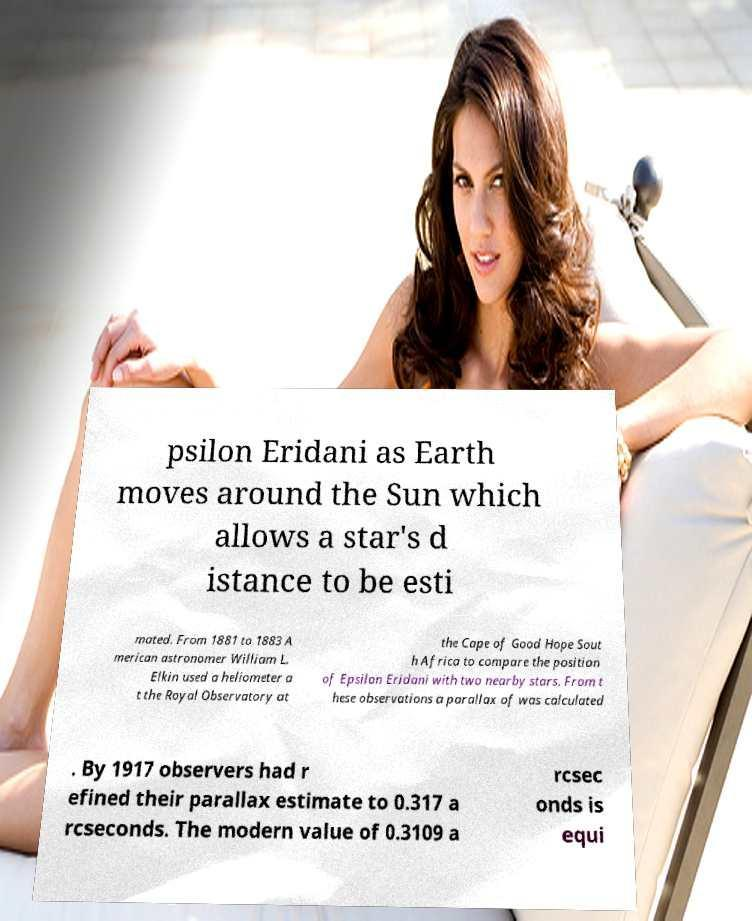For documentation purposes, I need the text within this image transcribed. Could you provide that? psilon Eridani as Earth moves around the Sun which allows a star's d istance to be esti mated. From 1881 to 1883 A merican astronomer William L. Elkin used a heliometer a t the Royal Observatory at the Cape of Good Hope Sout h Africa to compare the position of Epsilon Eridani with two nearby stars. From t hese observations a parallax of was calculated . By 1917 observers had r efined their parallax estimate to 0.317 a rcseconds. The modern value of 0.3109 a rcsec onds is equi 